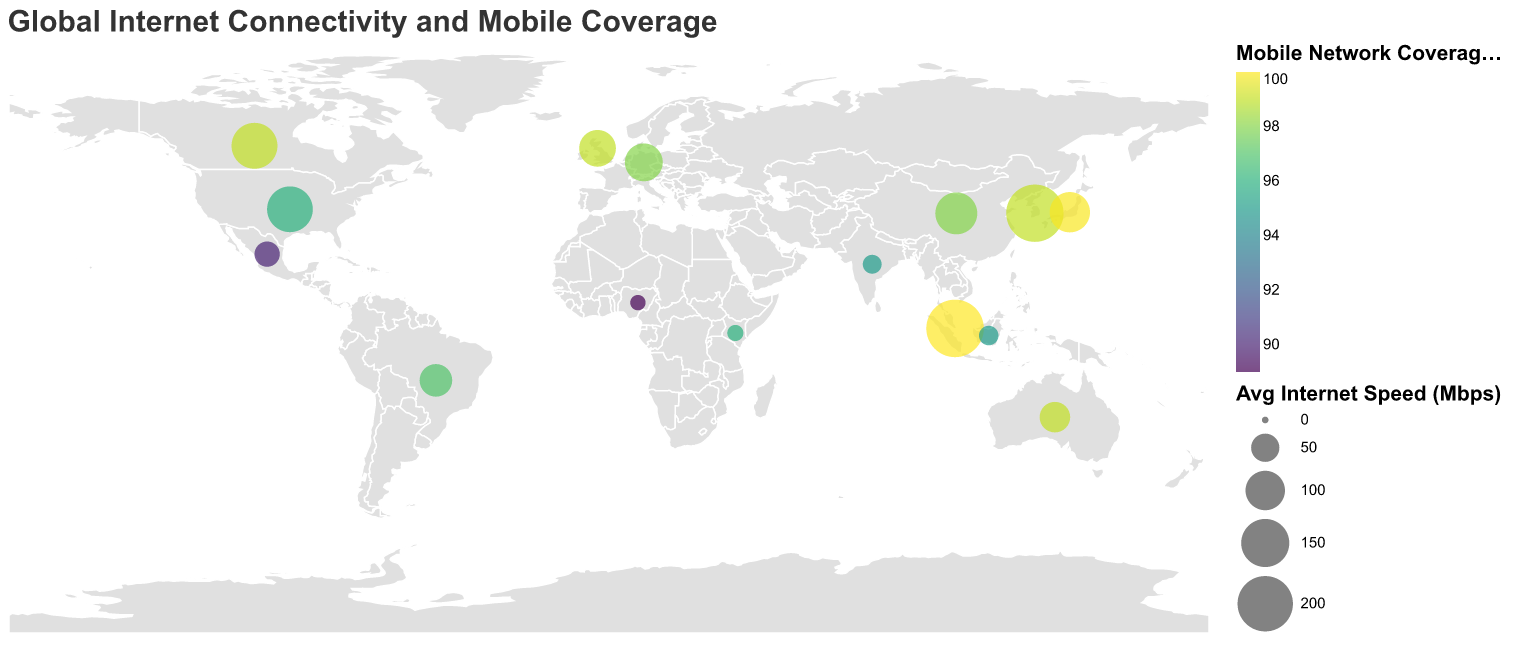How many countries have a mobile network coverage of 99% or higher? By observing the colors representing mobile network coverage, we can identify countries with high coverage. South Korea, Japan, United Kingdom, Australia, Singapore, and Canada have coverage of 99% or more.
Answer: 6 Which country has the highest average internet speed (Mbps)? By looking at the size of the circles, we identify Singapore as having the largest circle, representing the highest average internet speed of 215.83 Mbps.
Answer: Singapore What is the difference in average internet speed (Mbps) between Germany and India? The figure shows that Germany has an average internet speed of 92.35 Mbps and India has 20.69 Mbps. Subtracting these values gives 92.35 - 20.69 = 71.66 Mbps.
Answer: 71.66 Which country has the lowest smartphone penetration rate (%), and what is the value? By examining the tooltips indicating smartphone penetration, Kenya is identified with the lowest rate at 30.4%.
Answer: Kenya with 30.4% What is the average mobile network coverage (%) across all the countries in the figure? Add the mobile network coverage percentages of all countries and divide by the number of countries: (96 + 99 + 99.9 + 98 + 99 + 95 + 97 + 89 + 98 + 99 + 96 + 100 + 99 + 90 + 95) / 15 = 95.27%.
Answer: 95.27 Which country has a higher smartphone penetration rate (%), Brazil or Mexico? By comparing the smartphone penetration rates, Brazil has a rate of 70.0% and Mexico has a rate of 69.6%. Brazil has a higher penetration rate.
Answer: Brazil What is the median average internet speed (Mbps) for the countries shown? Sort the average internet speeds: 12.72, 14.30, 20.69, 22.32, 39.52, 58.83, 67.45, 86.54, 92.35, 104.63, 113.35, 135.54, 136.48, 214.47, 215.83. The middle value is 86.54 (United Kingdom).
Answer: 86.54 Which region has more dense high-speed internet coverage, Asia or South America? Observing the size of circles in these regions, South Korea, Japan, and Singapore in Asia show larger circles compared to Brazil in South America, indicating more dense high-speed internet coverage in Asia.
Answer: Asia What factors might contribute to the variation in mobile network coverage between countries? Various factors such as technological infrastructure, economic development, and geographic challenges affect mobile network coverage. Countries like South Korea and Japan generally have advanced technology and infrastructure, leading to higher coverage.
Answer: Technological infrastructure, economic development, geographic challenges Which country has the smallest average internet speed (Mbps) and what is the value? By comparing circle sizes, Nigeria has the smallest circle, representing an average internet speed of 12.72 Mbps.
Answer: Nigeria with 12.72 Mbps 